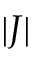Convert formula to latex. <formula><loc_0><loc_0><loc_500><loc_500>| J |</formula> 